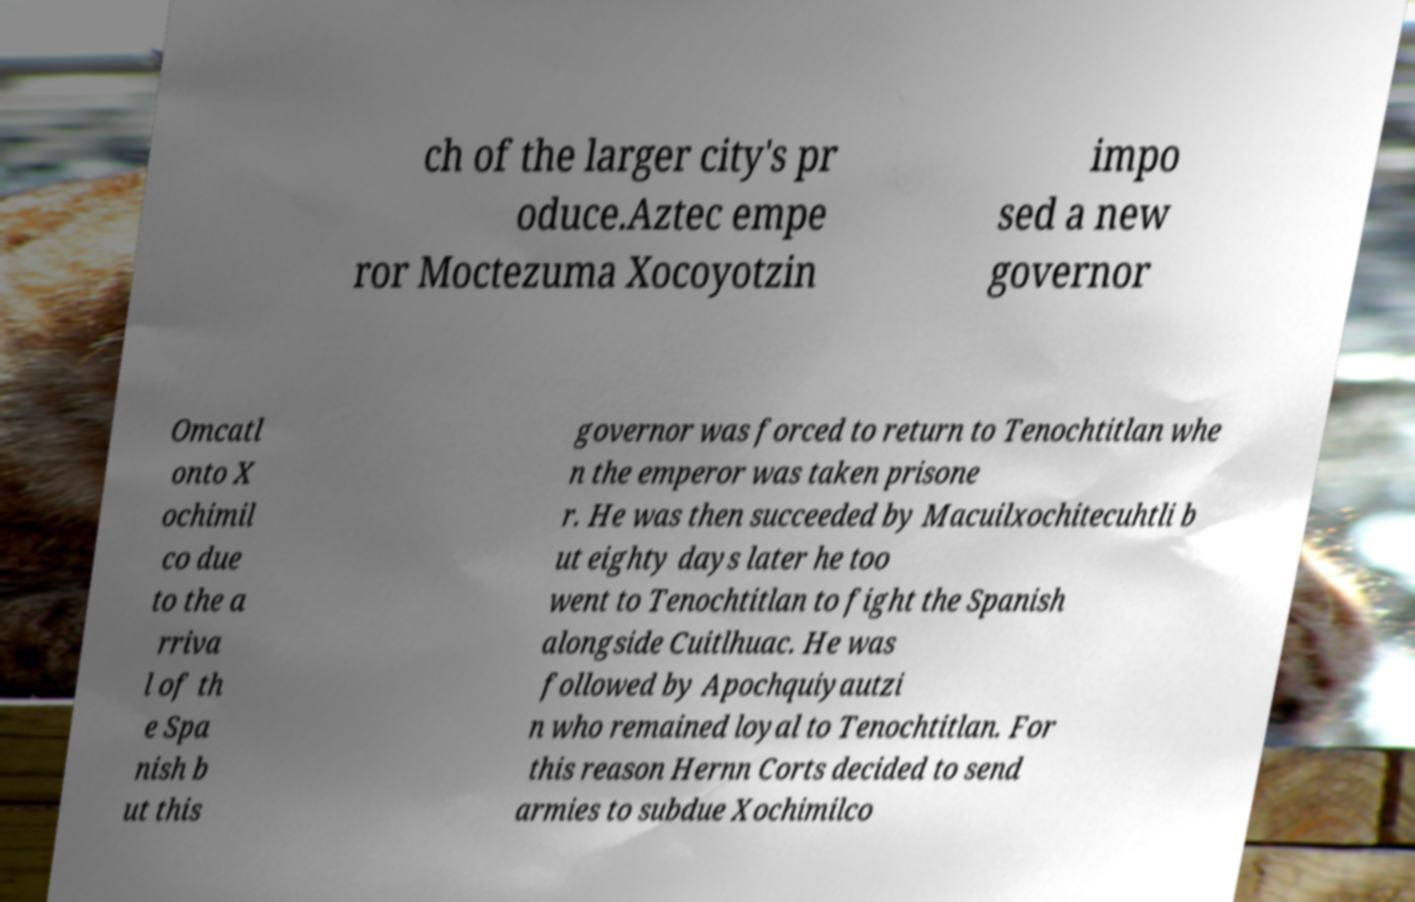Could you extract and type out the text from this image? ch of the larger city's pr oduce.Aztec empe ror Moctezuma Xocoyotzin impo sed a new governor Omcatl onto X ochimil co due to the a rriva l of th e Spa nish b ut this governor was forced to return to Tenochtitlan whe n the emperor was taken prisone r. He was then succeeded by Macuilxochitecuhtli b ut eighty days later he too went to Tenochtitlan to fight the Spanish alongside Cuitlhuac. He was followed by Apochquiyautzi n who remained loyal to Tenochtitlan. For this reason Hernn Corts decided to send armies to subdue Xochimilco 